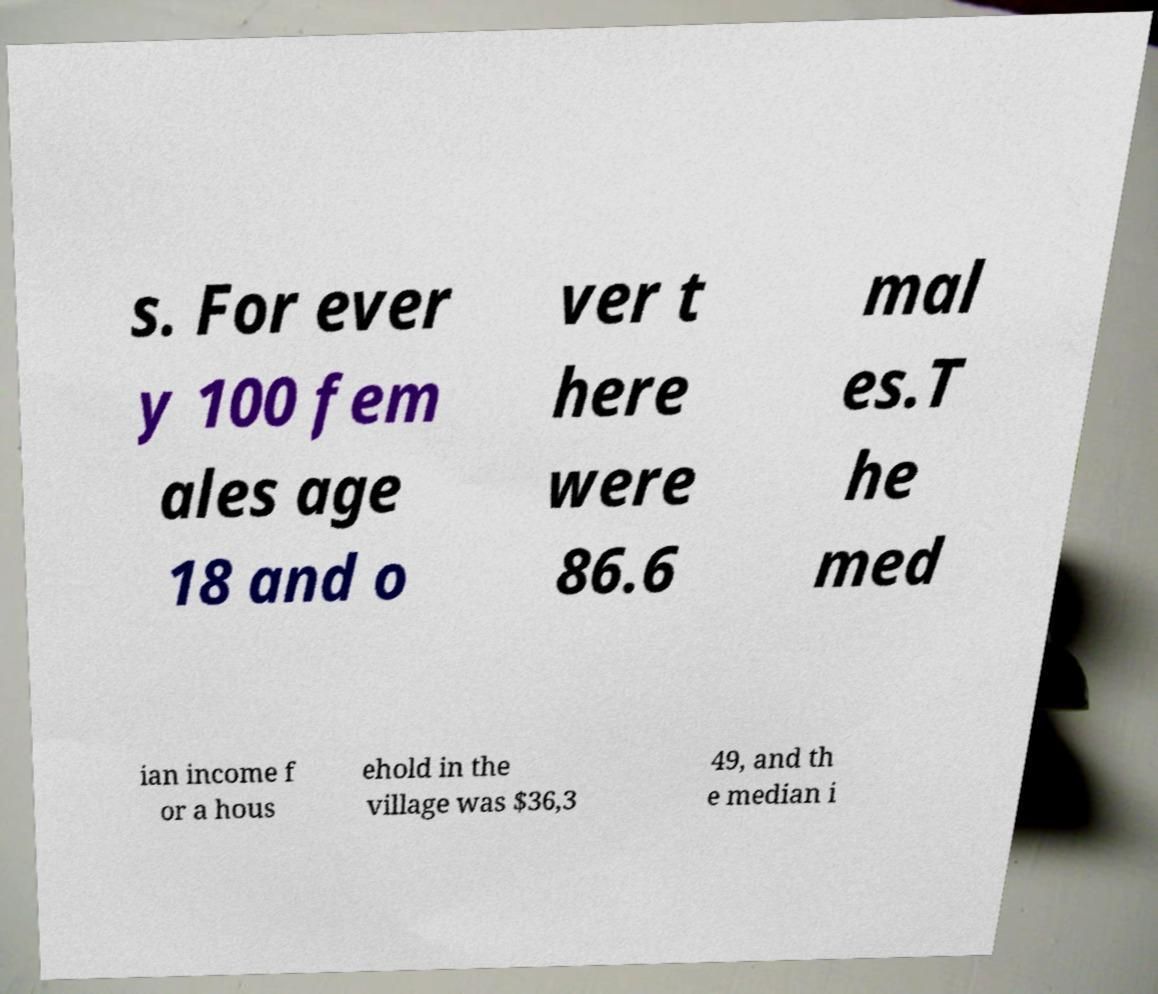I need the written content from this picture converted into text. Can you do that? s. For ever y 100 fem ales age 18 and o ver t here were 86.6 mal es.T he med ian income f or a hous ehold in the village was $36,3 49, and th e median i 